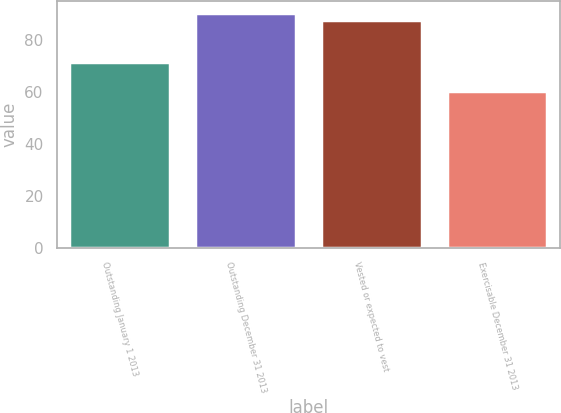Convert chart to OTSL. <chart><loc_0><loc_0><loc_500><loc_500><bar_chart><fcel>Outstanding January 1 2013<fcel>Outstanding December 31 2013<fcel>Vested or expected to vest<fcel>Exercisable December 31 2013<nl><fcel>71.34<fcel>90.52<fcel>87.76<fcel>60.49<nl></chart> 